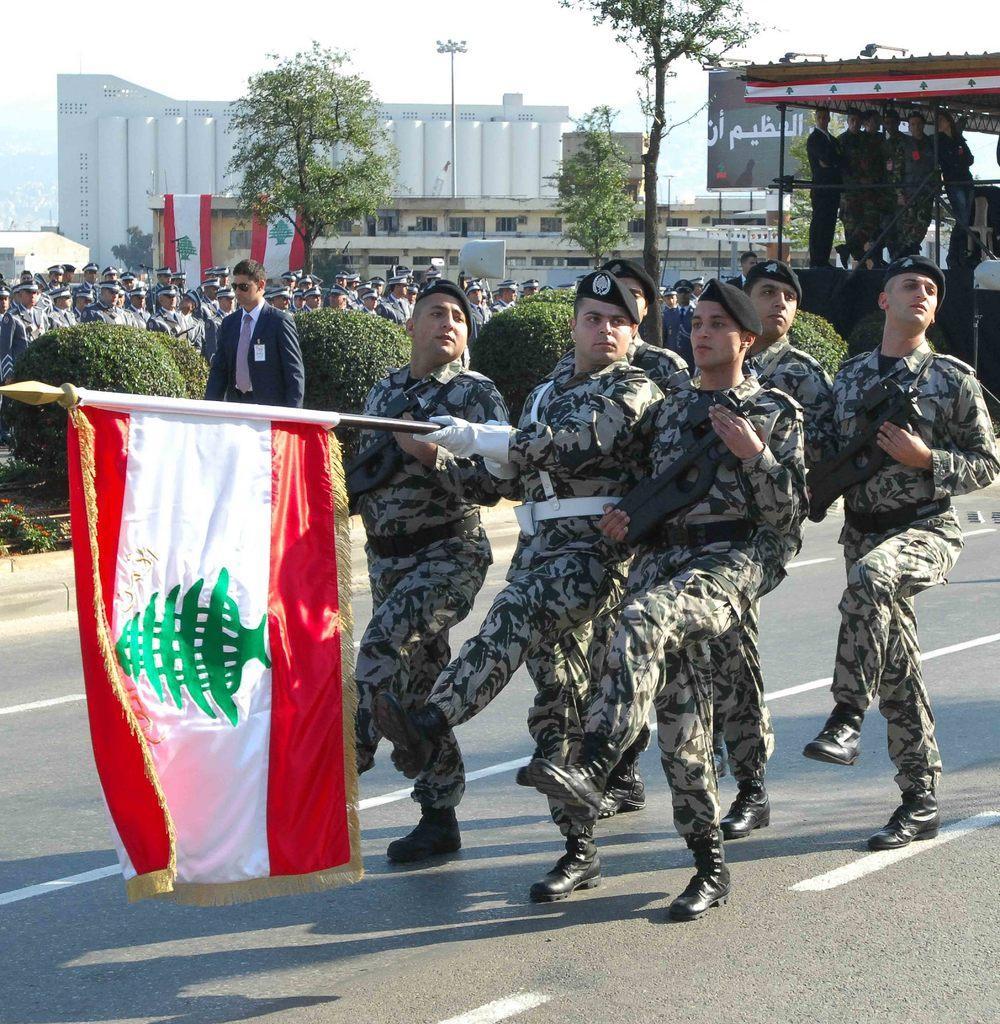In one or two sentences, can you explain what this image depicts? In this picture I can see there are group of people marching and holding a flag in their hands. There is a person walking here and there is a group of people here and there are some plants, trees, poles, buildings in the backdrop. 